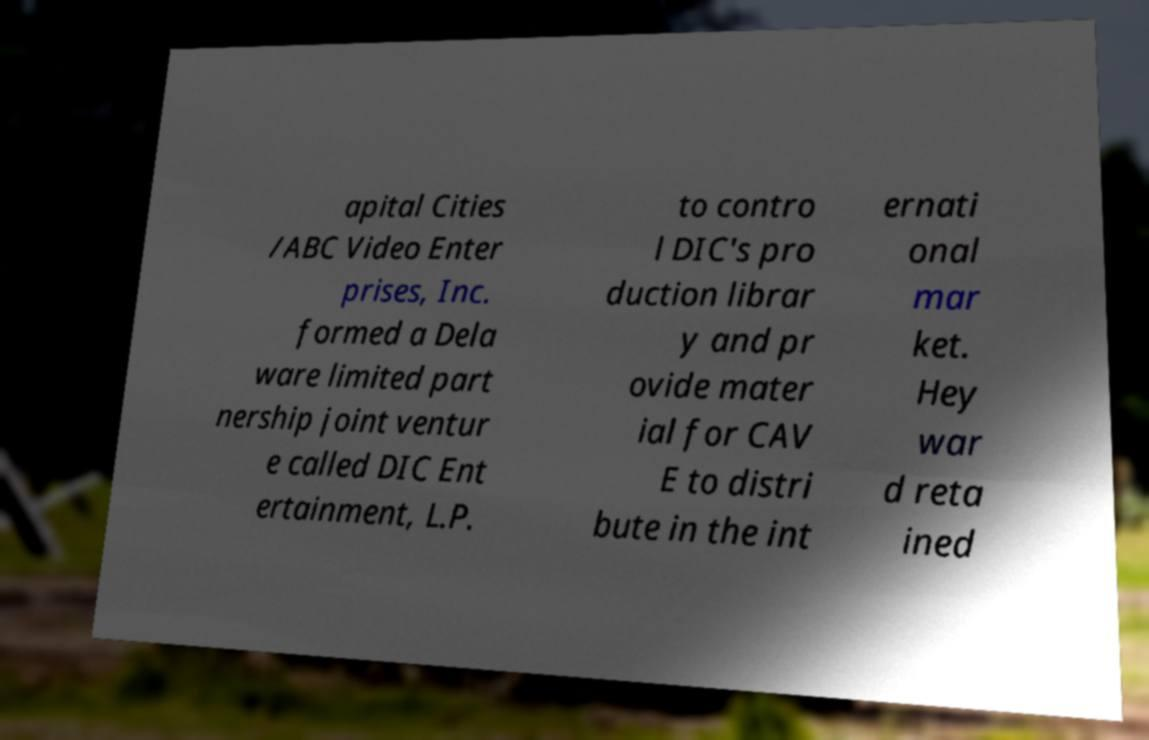Can you read and provide the text displayed in the image?This photo seems to have some interesting text. Can you extract and type it out for me? apital Cities /ABC Video Enter prises, Inc. formed a Dela ware limited part nership joint ventur e called DIC Ent ertainment, L.P. to contro l DIC's pro duction librar y and pr ovide mater ial for CAV E to distri bute in the int ernati onal mar ket. Hey war d reta ined 